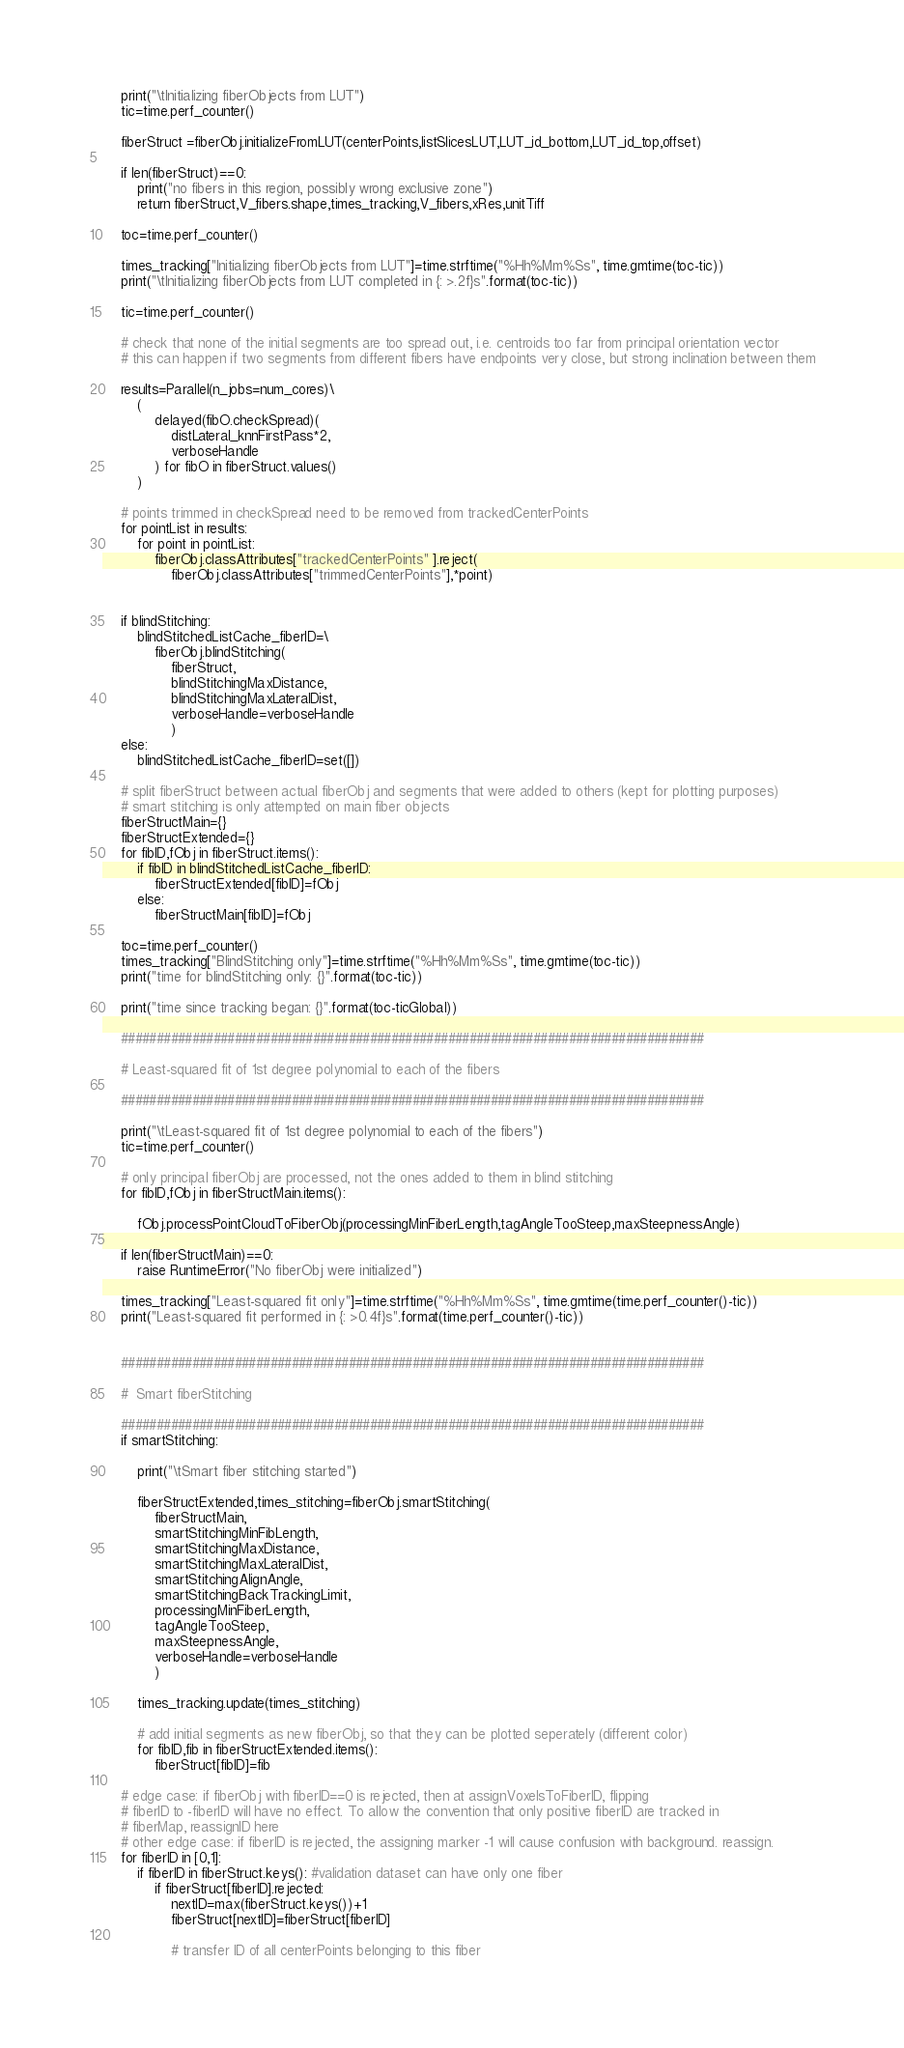<code> <loc_0><loc_0><loc_500><loc_500><_Python_>    print("\tInitializing fiberObjects from LUT")
    tic=time.perf_counter()

    fiberStruct =fiberObj.initializeFromLUT(centerPoints,listSlicesLUT,LUT_id_bottom,LUT_id_top,offset)
        
    if len(fiberStruct)==0:
        print("no fibers in this region, possibly wrong exclusive zone")
        return fiberStruct,V_fibers.shape,times_tracking,V_fibers,xRes,unitTiff

    toc=time.perf_counter()

    times_tracking["Initializing fiberObjects from LUT"]=time.strftime("%Hh%Mm%Ss", time.gmtime(toc-tic))
    print("\tInitializing fiberObjects from LUT completed in {: >.2f}s".format(toc-tic))

    tic=time.perf_counter()    

    # check that none of the initial segments are too spread out, i.e. centroids too far from principal orientation vector
    # this can happen if two segments from different fibers have endpoints very close, but strong inclination between them

    results=Parallel(n_jobs=num_cores)\
        (
            delayed(fibO.checkSpread)(
                distLateral_knnFirstPass*2,
                verboseHandle
            ) for fibO in fiberStruct.values() 
        )

    # points trimmed in checkSpread need to be removed from trackedCenterPoints
    for pointList in results:
        for point in pointList:
            fiberObj.classAttributes["trackedCenterPoints" ].reject(
                fiberObj.classAttributes["trimmedCenterPoints"],*point)


    if blindStitching:
        blindStitchedListCache_fiberID=\
            fiberObj.blindStitching(
                fiberStruct,
                blindStitchingMaxDistance,
                blindStitchingMaxLateralDist,
                verboseHandle=verboseHandle
                )
    else:
        blindStitchedListCache_fiberID=set([])

    # split fiberStruct between actual fiberObj and segments that were added to others (kept for plotting purposes)
    # smart stitching is only attempted on main fiber objects
    fiberStructMain={}
    fiberStructExtended={}
    for fibID,fObj in fiberStruct.items():
        if fibID in blindStitchedListCache_fiberID:
            fiberStructExtended[fibID]=fObj
        else:
            fiberStructMain[fibID]=fObj

    toc=time.perf_counter()
    times_tracking["BlindStitching only"]=time.strftime("%Hh%Mm%Ss", time.gmtime(toc-tic))
    print("time for blindStitching only: {}".format(toc-tic))

    print("time since tracking began: {}".format(toc-ticGlobal))

    ##################################################################################

    # Least-squared fit of 1st degree polynomial to each of the fibers

    ##################################################################################

    print("\tLeast-squared fit of 1st degree polynomial to each of the fibers")
    tic=time.perf_counter()

    # only principal fiberObj are processed, not the ones added to them in blind stitching
    for fibID,fObj in fiberStructMain.items():

        fObj.processPointCloudToFiberObj(processingMinFiberLength,tagAngleTooSteep,maxSteepnessAngle)

    if len(fiberStructMain)==0:
        raise RuntimeError("No fiberObj were initialized")

    times_tracking["Least-squared fit only"]=time.strftime("%Hh%Mm%Ss", time.gmtime(time.perf_counter()-tic))
    print("Least-squared fit performed in {: >0.4f}s".format(time.perf_counter()-tic))


    ##################################################################################

    #  Smart fiberStitching

    ##################################################################################
    if smartStitching:

        print("\tSmart fiber stitching started")

        fiberStructExtended,times_stitching=fiberObj.smartStitching(
            fiberStructMain,
            smartStitchingMinFibLength,
            smartStitchingMaxDistance,
            smartStitchingMaxLateralDist,
            smartStitchingAlignAngle,
            smartStitchingBackTrackingLimit,
            processingMinFiberLength,
            tagAngleTooSteep,
            maxSteepnessAngle,
            verboseHandle=verboseHandle
            )

        times_tracking.update(times_stitching)

        # add initial segments as new fiberObj, so that they can be plotted seperately (different color)
        for fibID,fib in fiberStructExtended.items():
            fiberStruct[fibID]=fib

    # edge case: if fiberObj with fiberID==0 is rejected, then at assignVoxelsToFiberID, flipping
    # fiberID to -fiberID will have no effect. To allow the convention that only positive fiberID are tracked in
    # fiberMap, reassignID here
    # other edge case: if fiberID is rejected, the assigning marker -1 will cause confusion with background. reassign. 
    for fiberID in [0,1]:
        if fiberID in fiberStruct.keys(): #validation dataset can have only one fiber
            if fiberStruct[fiberID].rejected:
                nextID=max(fiberStruct.keys())+1
                fiberStruct[nextID]=fiberStruct[fiberID]

                # transfer ID of all centerPoints belonging to this fiber</code> 